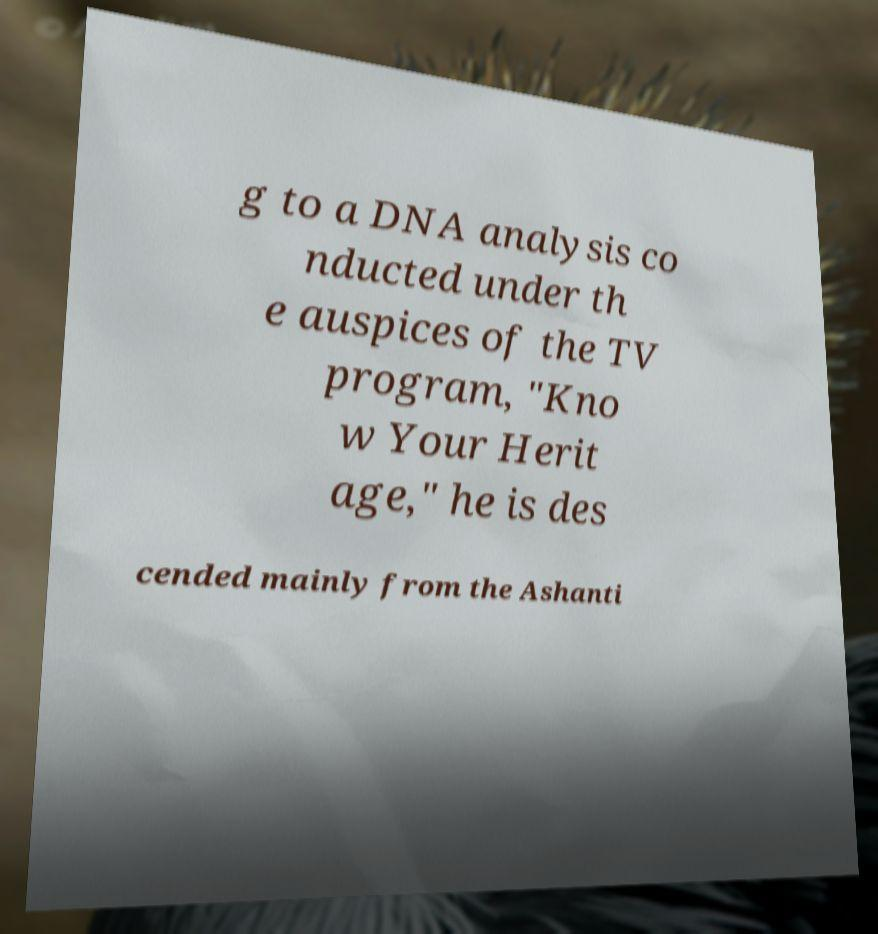For documentation purposes, I need the text within this image transcribed. Could you provide that? g to a DNA analysis co nducted under th e auspices of the TV program, "Kno w Your Herit age," he is des cended mainly from the Ashanti 